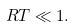<formula> <loc_0><loc_0><loc_500><loc_500>R T \ll 1 .</formula> 